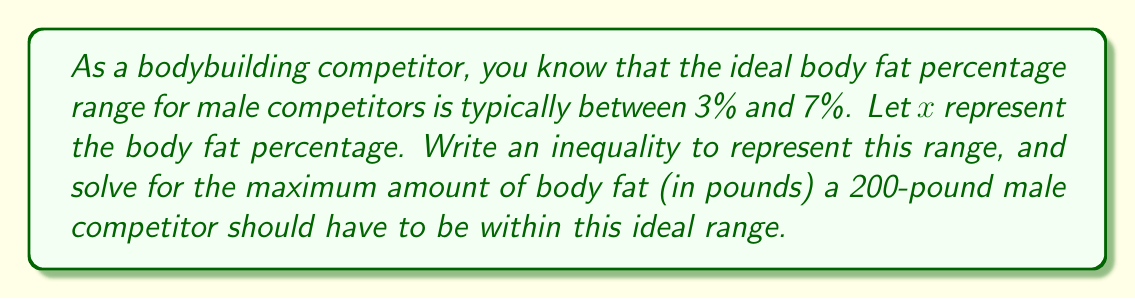Could you help me with this problem? Let's approach this step-by-step:

1) First, we need to express the ideal body fat percentage range as an inequality:

   $3 \leq x \leq 7$

2) Now, we want to find the maximum amount of body fat in pounds. This corresponds to the upper limit of the range, 7%.

3) To convert the percentage to pounds, we use the following formula:
   
   Body fat (lbs) = Total body weight (lbs) × Body fat percentage

4) In this case:
   
   Maximum body fat (lbs) = 200 lbs × 7%
   
   $= 200 \times \frac{7}{100} = 14$ lbs

Therefore, the maximum amount of body fat a 200-pound male competitor should have to be within the ideal range is 14 pounds.

5) We can express this as an inequality:

   $0 \leq \text{Body fat (lbs)} \leq 14$

This inequality represents the range of body fat in pounds that a 200-pound male competitor should have to be within the ideal body fat percentage range for competition.
Answer: The inequality representing the ideal body fat percentage range is:
$3 \leq x \leq 7$, where $x$ is the body fat percentage.

The maximum amount of body fat for a 200-pound male competitor within this range is 14 pounds, which can be expressed as:
$0 \leq \text{Body fat (lbs)} \leq 14$ 